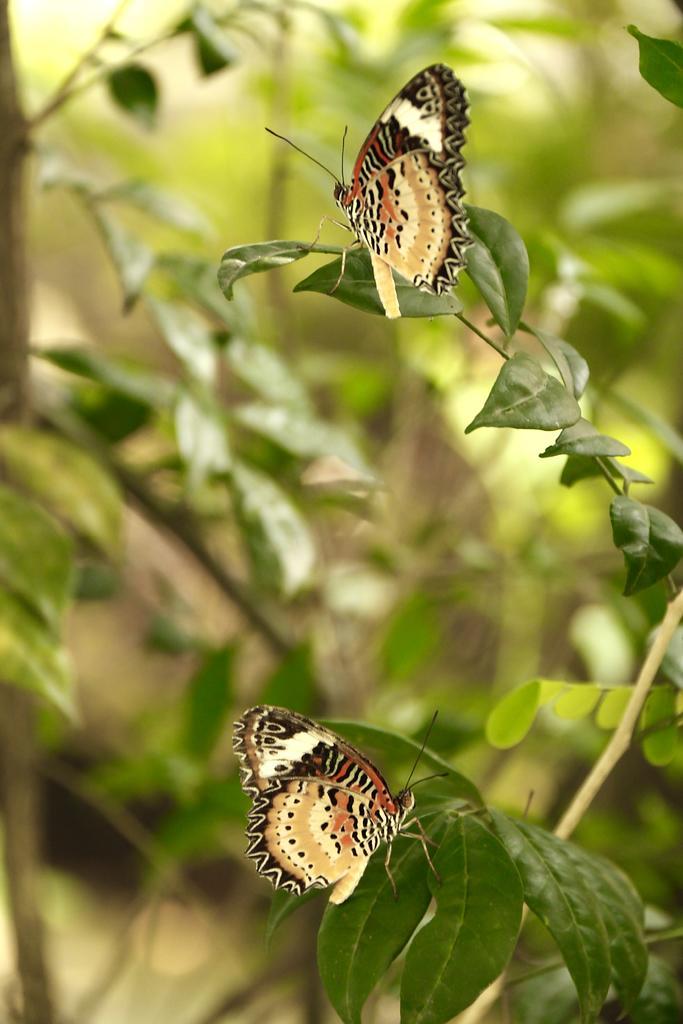Could you give a brief overview of what you see in this image? There are butterflies on the leaves in the foreground area of the image and greenery in the background. 